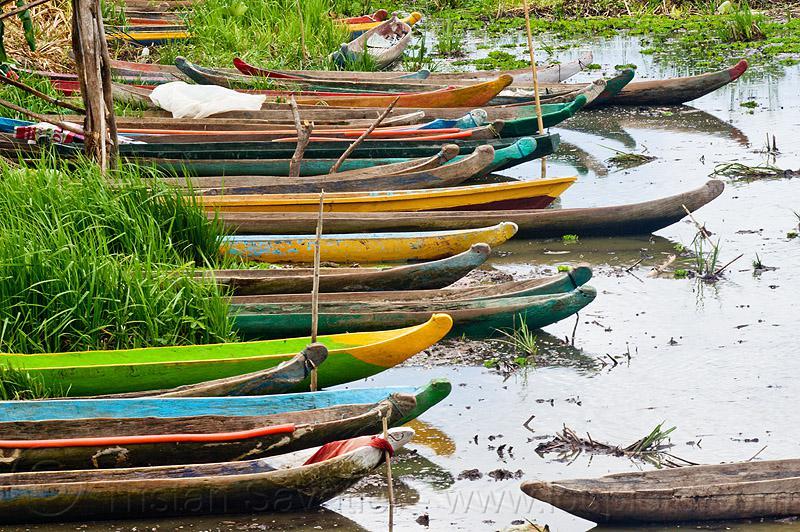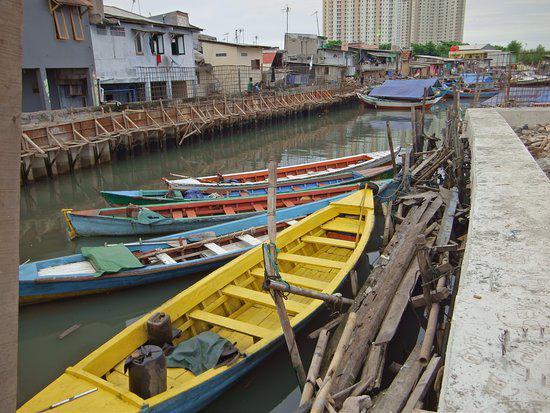The first image is the image on the left, the second image is the image on the right. Analyze the images presented: Is the assertion "There are exactly two boats in the image on the right." valid? Answer yes or no. No. The first image is the image on the left, the second image is the image on the right. Evaluate the accuracy of this statement regarding the images: "One of the images contains exactly two canoes.". Is it true? Answer yes or no. No. 